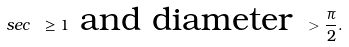<formula> <loc_0><loc_0><loc_500><loc_500>s e c \ \geq 1 \text { and diameter } > \frac { \pi } { 2 } .</formula> 